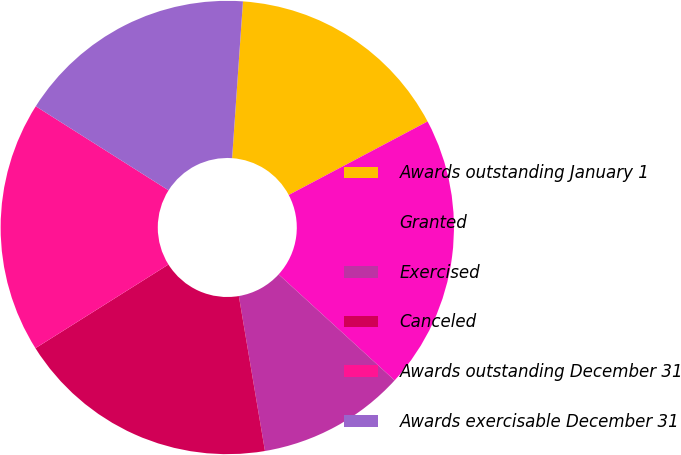Convert chart to OTSL. <chart><loc_0><loc_0><loc_500><loc_500><pie_chart><fcel>Awards outstanding January 1<fcel>Granted<fcel>Exercised<fcel>Canceled<fcel>Awards outstanding December 31<fcel>Awards exercisable December 31<nl><fcel>16.15%<fcel>19.53%<fcel>10.56%<fcel>18.72%<fcel>17.92%<fcel>17.12%<nl></chart> 